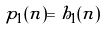<formula> <loc_0><loc_0><loc_500><loc_500>p _ { 1 } ( n ) = h _ { 1 } ( n )</formula> 